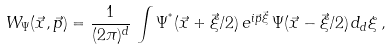Convert formula to latex. <formula><loc_0><loc_0><loc_500><loc_500>W _ { \Psi } ( \vec { x } , \vec { p } ) = \frac { 1 } { ( 2 \pi ) ^ { d } } \, \int \Psi ^ { ^ { * } } ( \vec { x } + \vec { \xi } / 2 ) \, e ^ { { i \vec { p } \vec { \xi } } } \, \Psi ( \vec { x } - \vec { \xi } / 2 ) \, d _ { d } \xi \, ,</formula> 